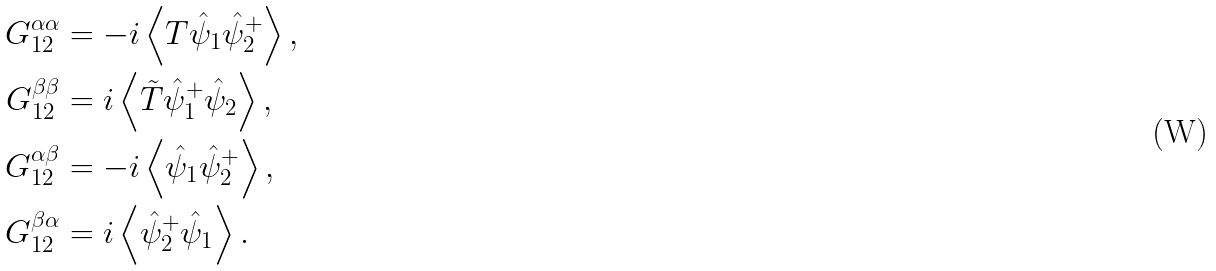Convert formula to latex. <formula><loc_0><loc_0><loc_500><loc_500>G _ { 1 2 } ^ { \alpha \alpha } & = - i \left < T \hat { \psi } _ { 1 } \hat { \psi } _ { 2 } ^ { + } \right > , \\ G _ { 1 2 } ^ { \beta \beta } & = i \left < \tilde { T } \hat { \psi } _ { 1 } ^ { + } \hat { \psi } _ { 2 } \right > , \\ G _ { 1 2 } ^ { \alpha \beta } & = - i \left < \hat { \psi } _ { 1 } \hat { \psi } _ { 2 } ^ { + } \right > , \\ G _ { 1 2 } ^ { \beta \alpha } & = i \left < \hat { \psi } _ { 2 } ^ { + } \hat { \psi } _ { 1 } \right > .</formula> 